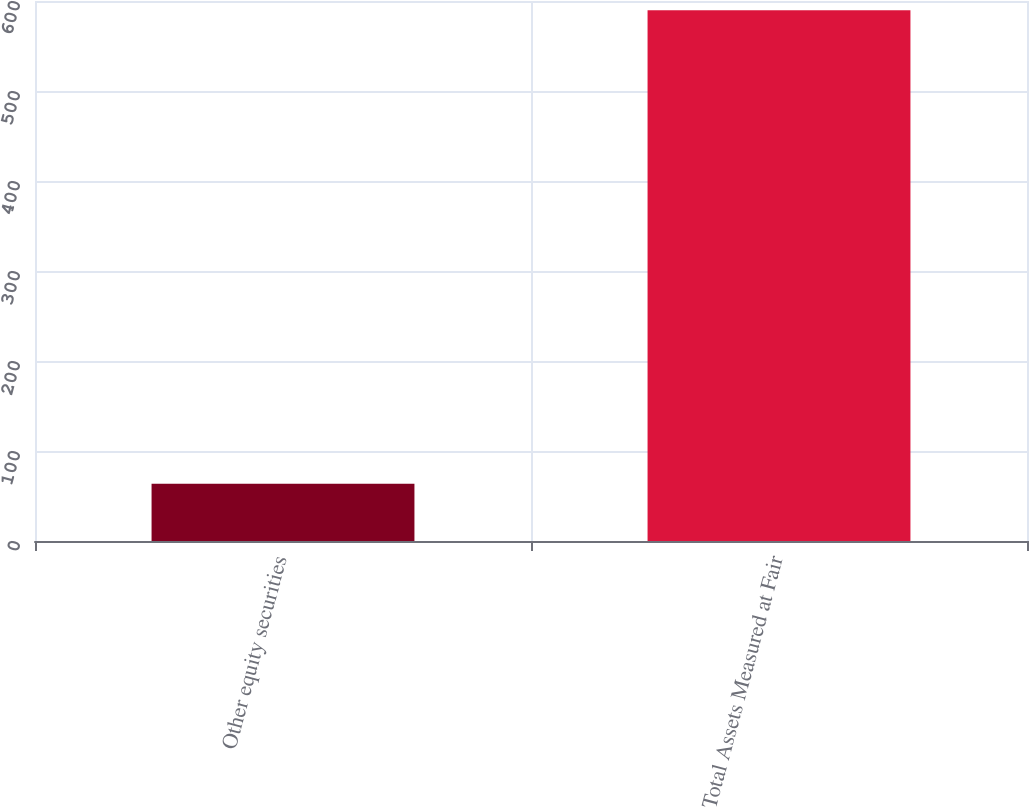Convert chart. <chart><loc_0><loc_0><loc_500><loc_500><bar_chart><fcel>Other equity securities<fcel>Total Assets Measured at Fair<nl><fcel>63.6<fcel>589.7<nl></chart> 